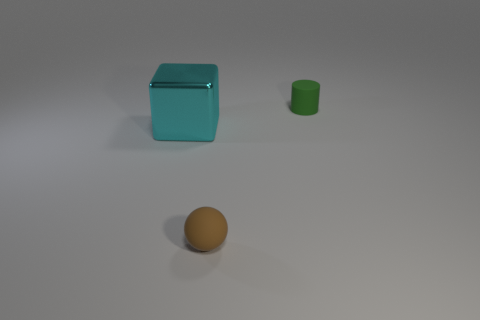Are there any other things that have the same size as the cyan cube?
Your answer should be very brief. No. Are there any other things that have the same material as the big cyan block?
Your response must be concise. No. What number of brown matte things are in front of the small matte object that is to the left of the small thing behind the big cyan shiny thing?
Ensure brevity in your answer.  0. Is the number of tiny green metal cylinders greater than the number of matte cylinders?
Provide a succinct answer. No. What number of things are there?
Your answer should be very brief. 3. There is a rubber thing that is to the left of the thing behind the cyan object that is to the left of the small green rubber object; what is its shape?
Offer a very short reply. Sphere. Are there fewer small green cylinders in front of the big cyan thing than cyan shiny blocks in front of the tiny green cylinder?
Offer a very short reply. Yes. There is a rubber thing that is in front of the small matte thing that is to the right of the tiny matte sphere; what is its shape?
Keep it short and to the point. Sphere. Are there any small things that have the same material as the green cylinder?
Ensure brevity in your answer.  Yes. There is a thing to the left of the brown ball; what material is it?
Offer a terse response. Metal. 